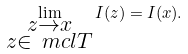<formula> <loc_0><loc_0><loc_500><loc_500>\lim _ { \substack { z \to x \\ z \in \ m c l { T } } } I ( z ) = I ( x ) .</formula> 